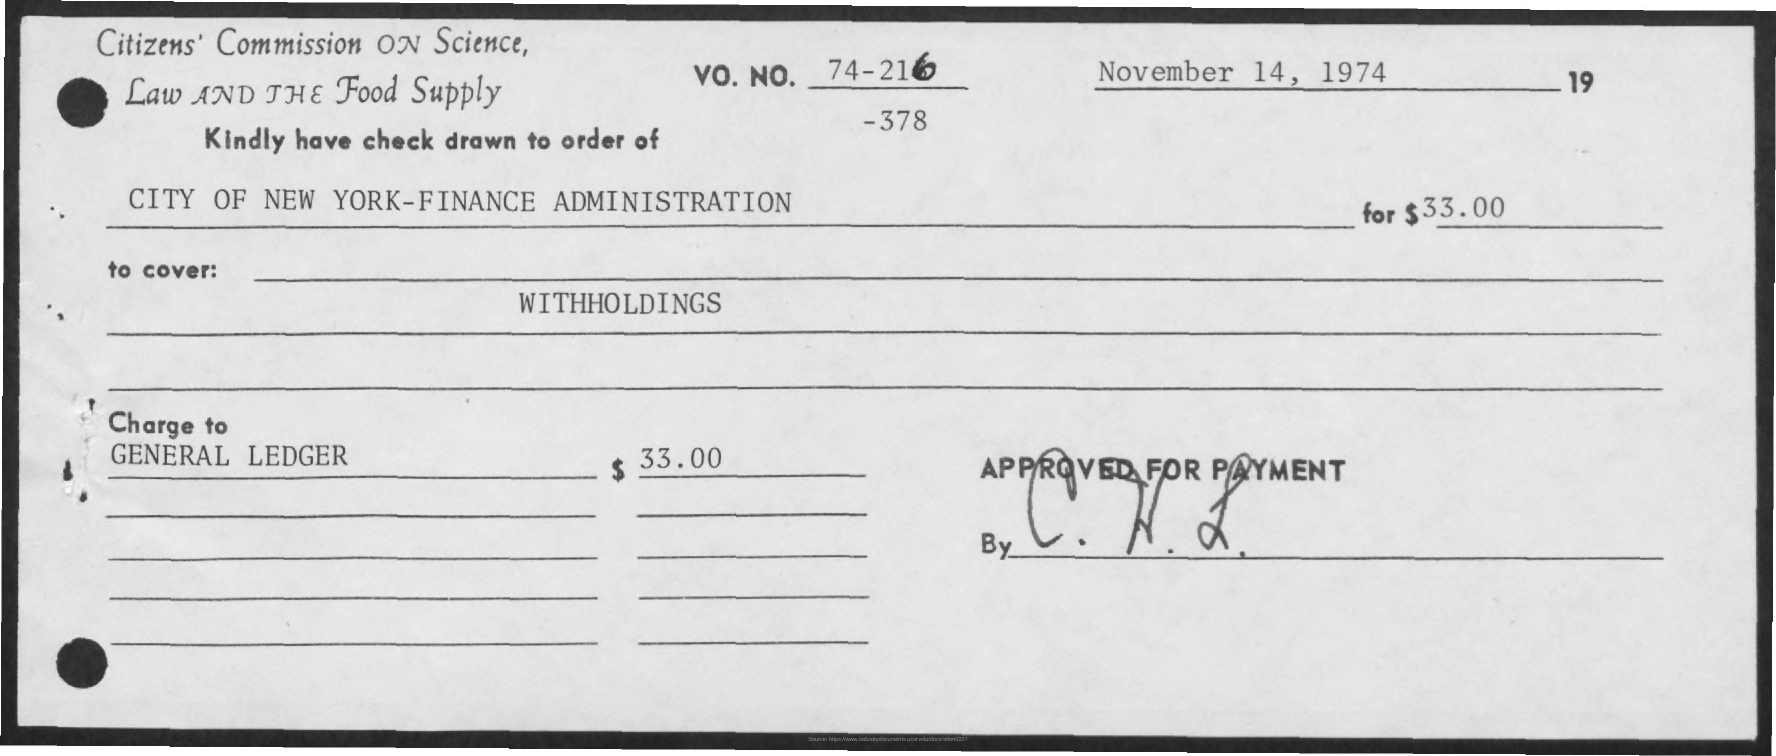How many dollars were written on the cheque?
 33.00 